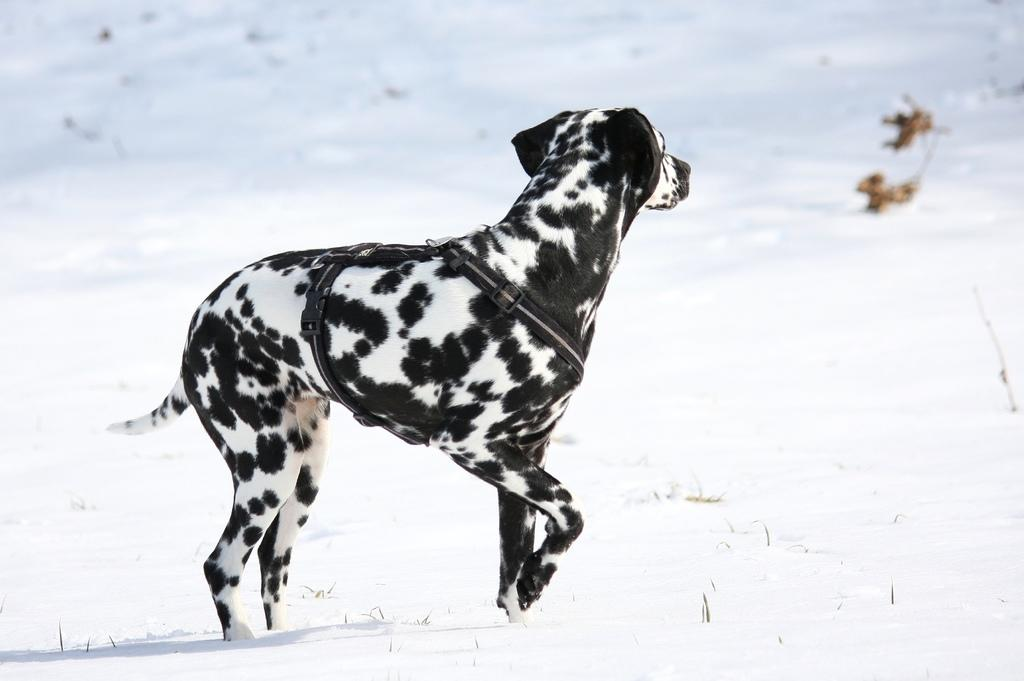What type of animal is in the image? There is a dalmatian dog in the image. What is the dog wearing? The dog is wearing a belt. What is the surface the dog is standing on? The dog is standing on snow. How would you describe the background of the image? The background of the image is blurred. How many oranges can be seen in the image? There are no oranges present in the image. What is the position of the sun in the image? There is no sun visible in the image. 